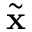<formula> <loc_0><loc_0><loc_500><loc_500>\tilde { x }</formula> 